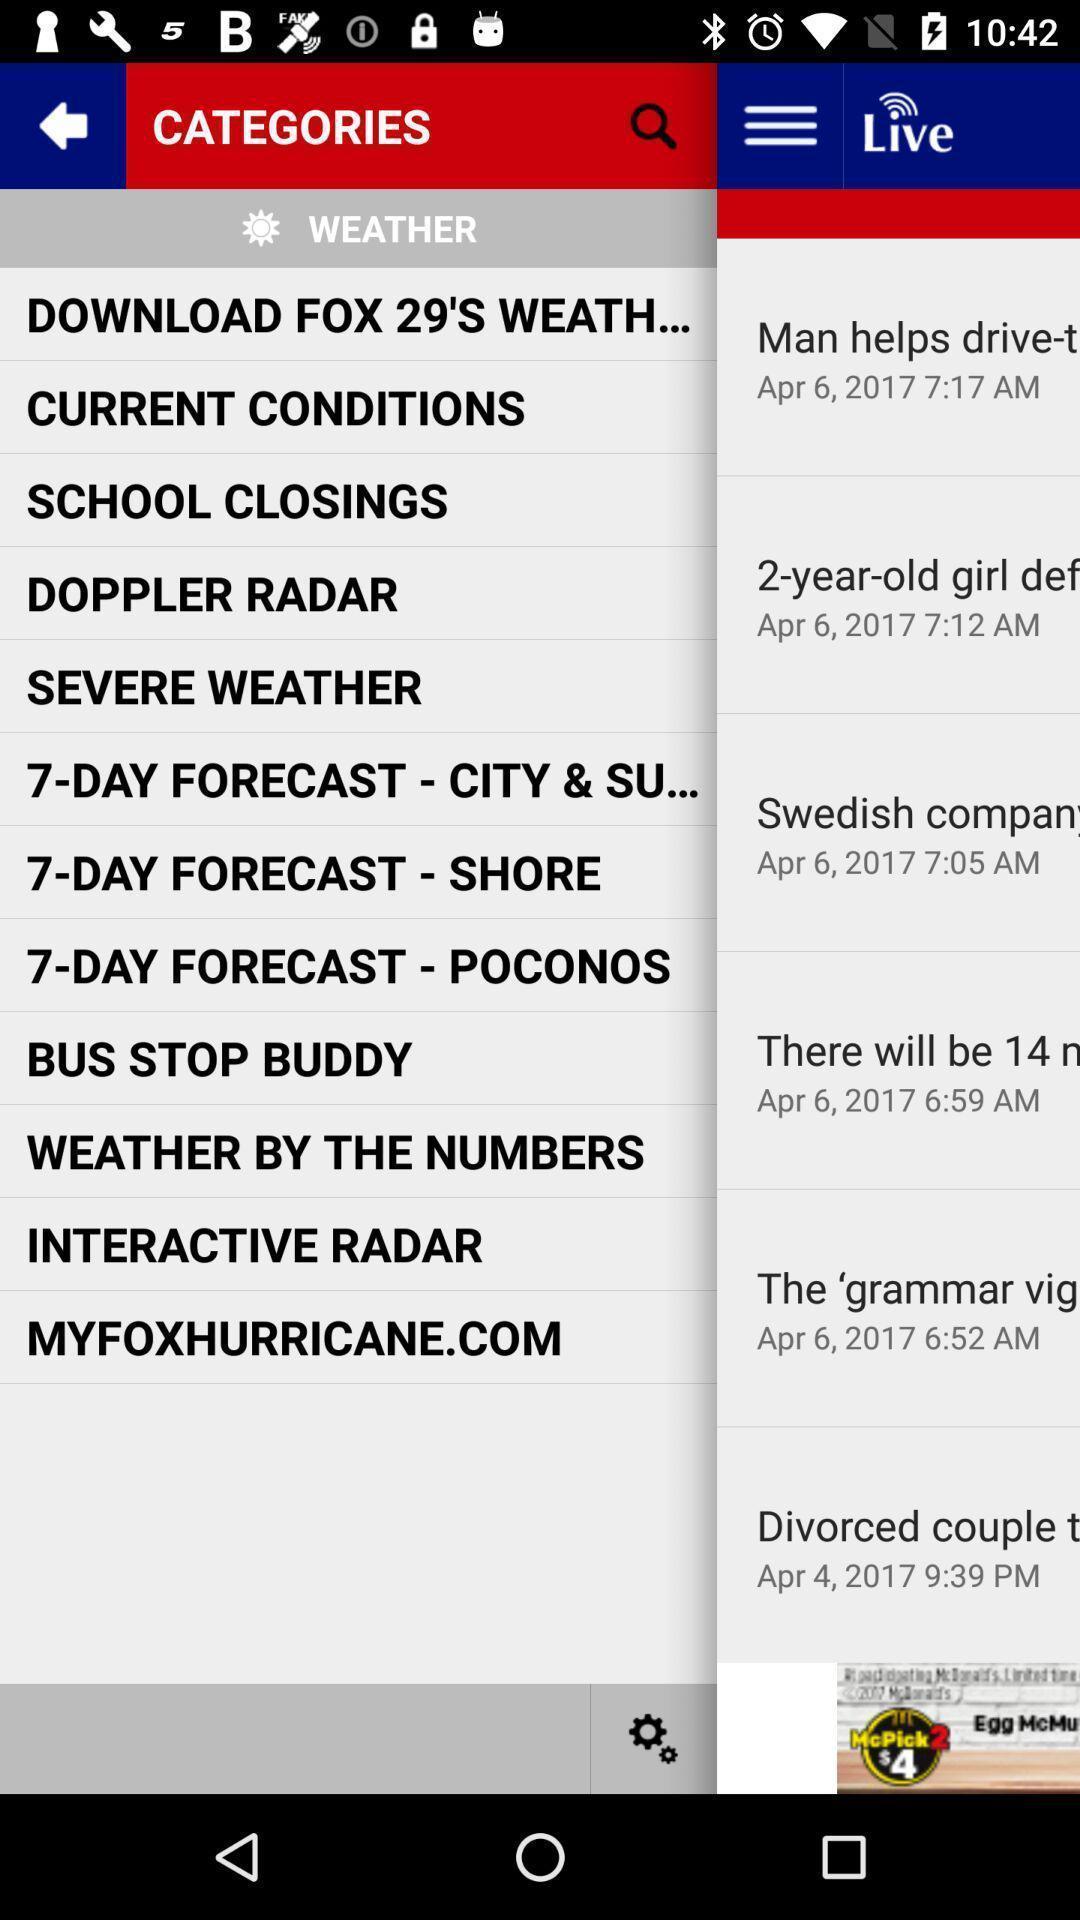Describe the visual elements of this screenshot. Pop-up showing menu for weather conditions. 